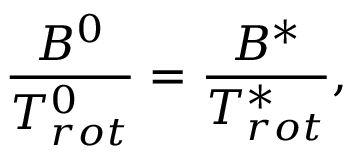Convert formula to latex. <formula><loc_0><loc_0><loc_500><loc_500>\frac { B ^ { 0 } } { T _ { r o t } ^ { 0 } } = \frac { B ^ { * } } { T _ { r o t } ^ { * } } ,</formula> 